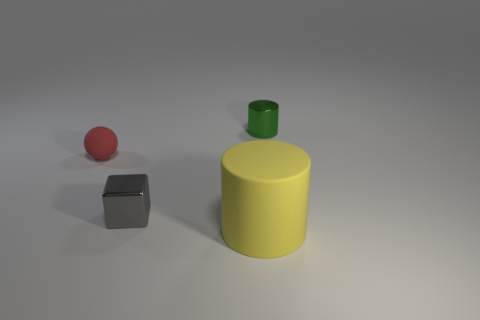Add 3 tiny matte things. How many objects exist? 7 Subtract all blocks. How many objects are left? 3 Add 1 red objects. How many red objects are left? 2 Add 4 tiny cyan metal cubes. How many tiny cyan metal cubes exist? 4 Subtract 0 gray cylinders. How many objects are left? 4 Subtract all small green cylinders. Subtract all blue objects. How many objects are left? 3 